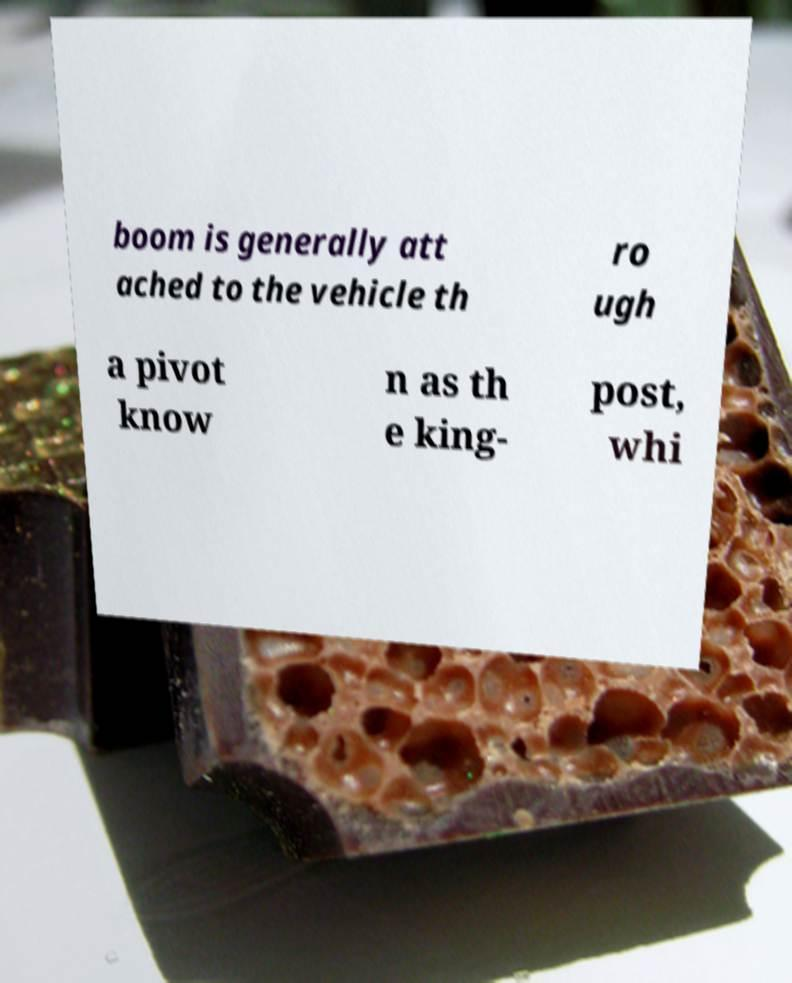Can you read and provide the text displayed in the image?This photo seems to have some interesting text. Can you extract and type it out for me? boom is generally att ached to the vehicle th ro ugh a pivot know n as th e king- post, whi 